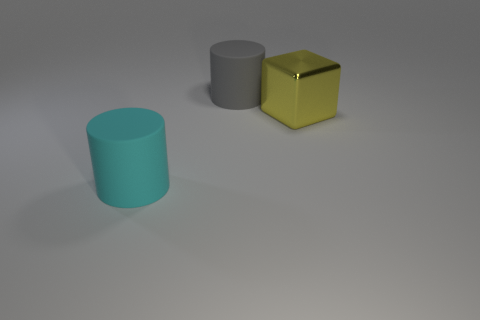Add 3 big purple matte cubes. How many objects exist? 6 Subtract all blocks. How many objects are left? 2 Subtract 0 purple spheres. How many objects are left? 3 Subtract all small green metallic objects. Subtract all large metallic cubes. How many objects are left? 2 Add 3 large rubber objects. How many large rubber objects are left? 5 Add 3 large yellow blocks. How many large yellow blocks exist? 4 